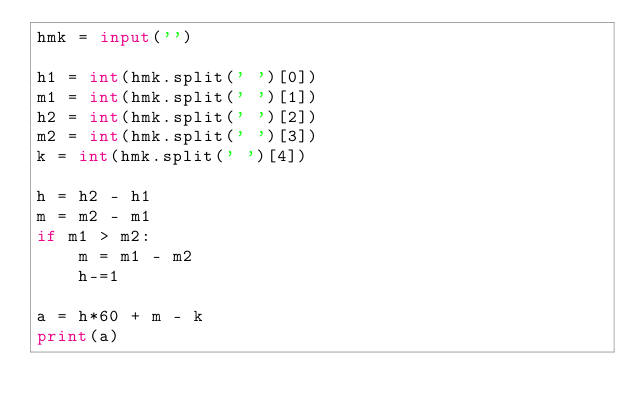<code> <loc_0><loc_0><loc_500><loc_500><_Python_>hmk = input('')

h1 = int(hmk.split(' ')[0])
m1 = int(hmk.split(' ')[1])
h2 = int(hmk.split(' ')[2])
m2 = int(hmk.split(' ')[3])
k = int(hmk.split(' ')[4])

h = h2 - h1
m = m2 - m1
if m1 > m2:
    m = m1 - m2
    h-=1

a = h*60 + m - k
print(a)</code> 